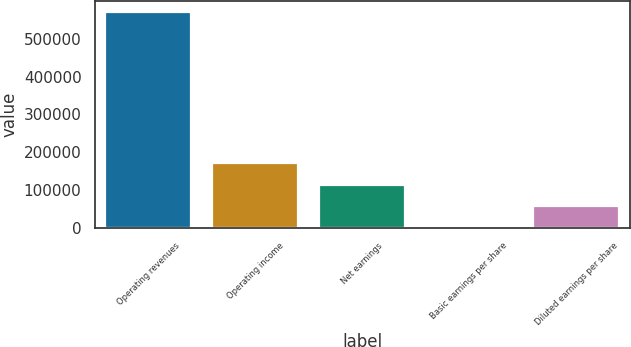<chart> <loc_0><loc_0><loc_500><loc_500><bar_chart><fcel>Operating revenues<fcel>Operating income<fcel>Net earnings<fcel>Basic earnings per share<fcel>Diluted earnings per share<nl><fcel>571213<fcel>171364<fcel>114243<fcel>0.14<fcel>57121.4<nl></chart> 